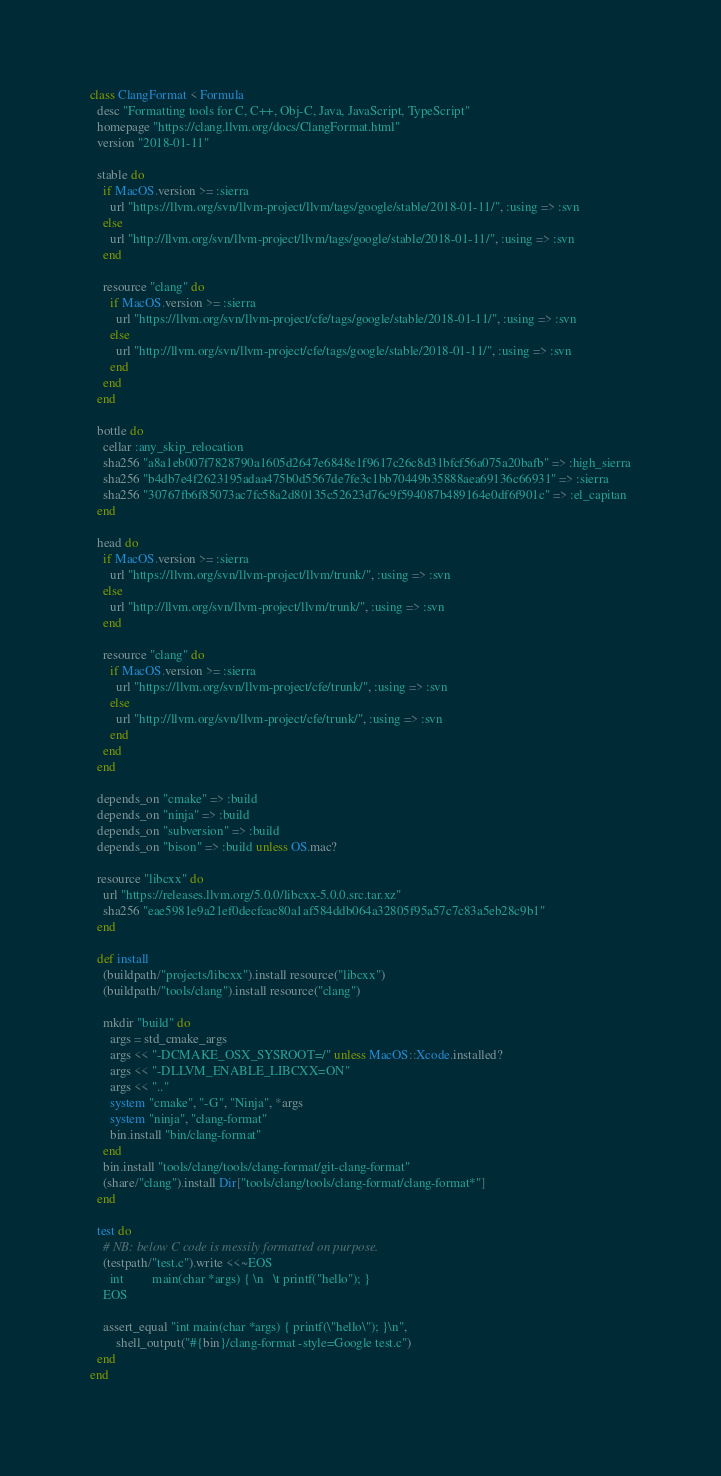Convert code to text. <code><loc_0><loc_0><loc_500><loc_500><_Ruby_>class ClangFormat < Formula
  desc "Formatting tools for C, C++, Obj-C, Java, JavaScript, TypeScript"
  homepage "https://clang.llvm.org/docs/ClangFormat.html"
  version "2018-01-11"

  stable do
    if MacOS.version >= :sierra
      url "https://llvm.org/svn/llvm-project/llvm/tags/google/stable/2018-01-11/", :using => :svn
    else
      url "http://llvm.org/svn/llvm-project/llvm/tags/google/stable/2018-01-11/", :using => :svn
    end

    resource "clang" do
      if MacOS.version >= :sierra
        url "https://llvm.org/svn/llvm-project/cfe/tags/google/stable/2018-01-11/", :using => :svn
      else
        url "http://llvm.org/svn/llvm-project/cfe/tags/google/stable/2018-01-11/", :using => :svn
      end
    end
  end

  bottle do
    cellar :any_skip_relocation
    sha256 "a8a1eb007f7828790a1605d2647e6848e1f9617c26c8d31bfcf56a075a20bafb" => :high_sierra
    sha256 "b4db7e4f2623195adaa475b0d5567de7fe3c1bb70449b35888aea69136c66931" => :sierra
    sha256 "30767fb6f85073ac7fc58a2d80135c52623d76c9f594087b489164e0df6f901c" => :el_capitan
  end

  head do
    if MacOS.version >= :sierra
      url "https://llvm.org/svn/llvm-project/llvm/trunk/", :using => :svn
    else
      url "http://llvm.org/svn/llvm-project/llvm/trunk/", :using => :svn
    end

    resource "clang" do
      if MacOS.version >= :sierra
        url "https://llvm.org/svn/llvm-project/cfe/trunk/", :using => :svn
      else
        url "http://llvm.org/svn/llvm-project/cfe/trunk/", :using => :svn
      end
    end
  end

  depends_on "cmake" => :build
  depends_on "ninja" => :build
  depends_on "subversion" => :build
  depends_on "bison" => :build unless OS.mac?

  resource "libcxx" do
    url "https://releases.llvm.org/5.0.0/libcxx-5.0.0.src.tar.xz"
    sha256 "eae5981e9a21ef0decfcac80a1af584ddb064a32805f95a57c7c83a5eb28c9b1"
  end

  def install
    (buildpath/"projects/libcxx").install resource("libcxx")
    (buildpath/"tools/clang").install resource("clang")

    mkdir "build" do
      args = std_cmake_args
      args << "-DCMAKE_OSX_SYSROOT=/" unless MacOS::Xcode.installed?
      args << "-DLLVM_ENABLE_LIBCXX=ON"
      args << ".."
      system "cmake", "-G", "Ninja", *args
      system "ninja", "clang-format"
      bin.install "bin/clang-format"
    end
    bin.install "tools/clang/tools/clang-format/git-clang-format"
    (share/"clang").install Dir["tools/clang/tools/clang-format/clang-format*"]
  end

  test do
    # NB: below C code is messily formatted on purpose.
    (testpath/"test.c").write <<~EOS
      int         main(char *args) { \n   \t printf("hello"); }
    EOS

    assert_equal "int main(char *args) { printf(\"hello\"); }\n",
        shell_output("#{bin}/clang-format -style=Google test.c")
  end
end
</code> 